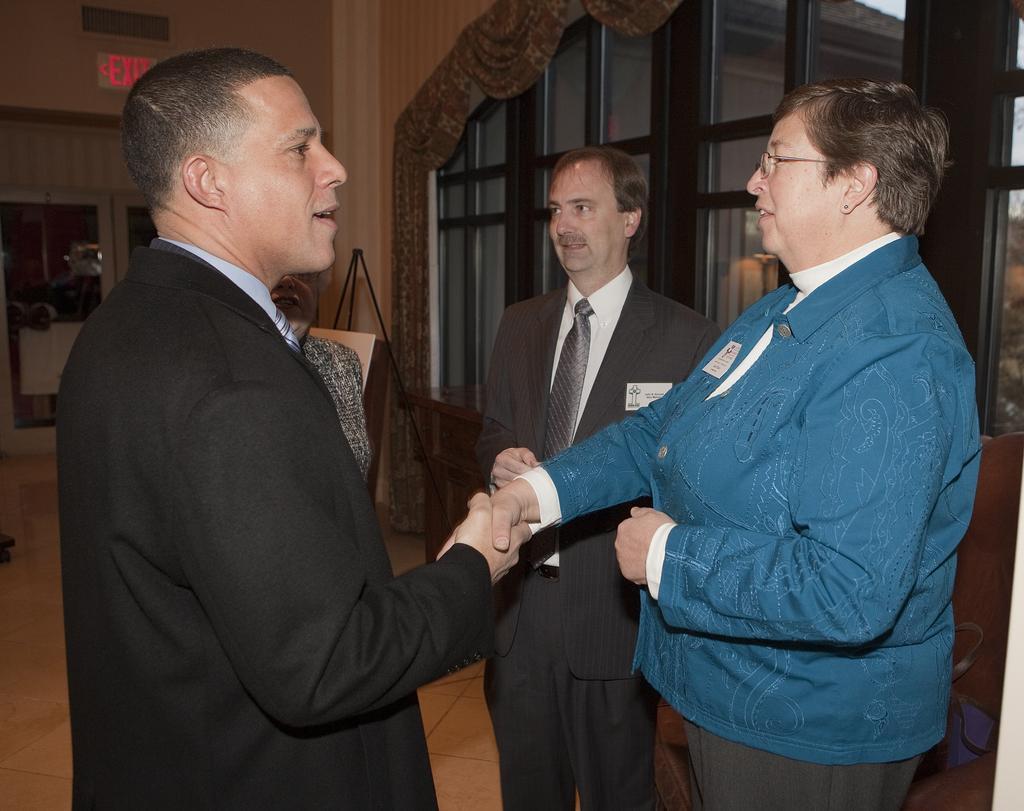Could you give a brief overview of what you see in this image? In this picture there are two persons standing and shaking hands of each other and there is another person standing beside them and there is a glass door in the left corner and there is a exit board above it and there are some other objects in the background. 